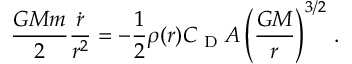<formula> <loc_0><loc_0><loc_500><loc_500>\frac { G M m } { 2 } \frac { \dot { r } } { r ^ { 2 } } = - \frac { 1 } { 2 } \rho ( r ) C _ { D } A \left ( \frac { G M } { r } \right ) ^ { 3 / 2 } \, .</formula> 